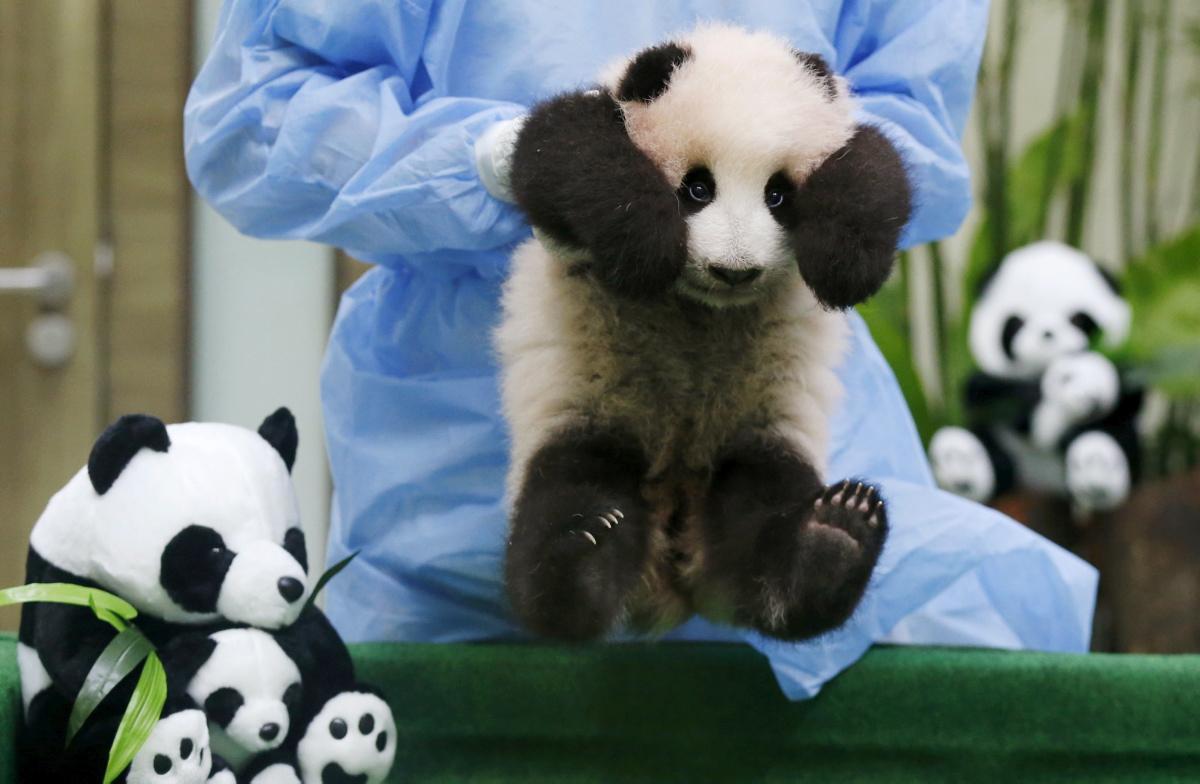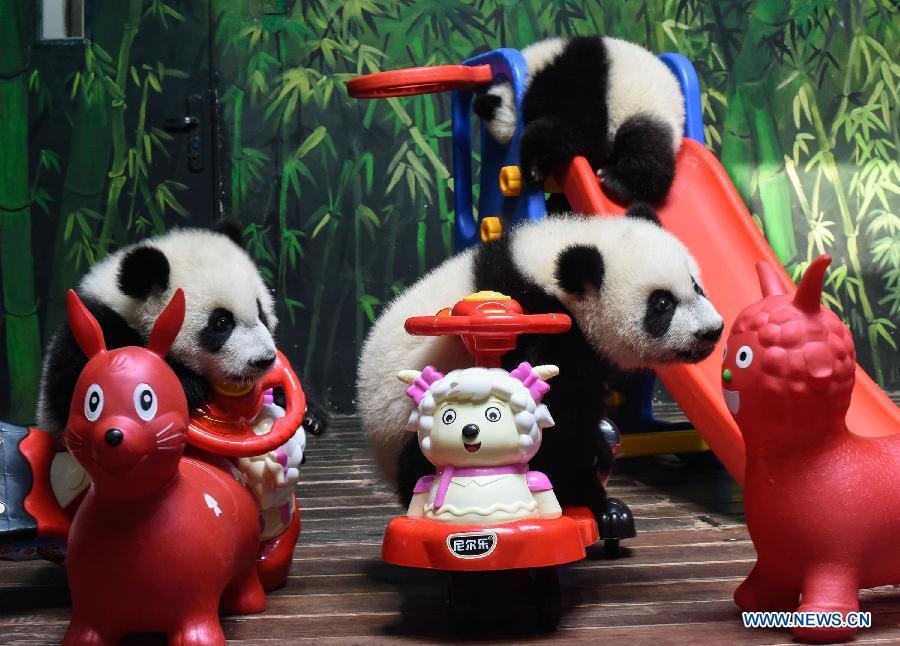The first image is the image on the left, the second image is the image on the right. Considering the images on both sides, is "People are interacting with a panda in the image on the left." valid? Answer yes or no. Yes. The first image is the image on the left, the second image is the image on the right. For the images displayed, is the sentence "An image shows at least one person in protective gear behind a panda, grasping it" factually correct? Answer yes or no. Yes. 